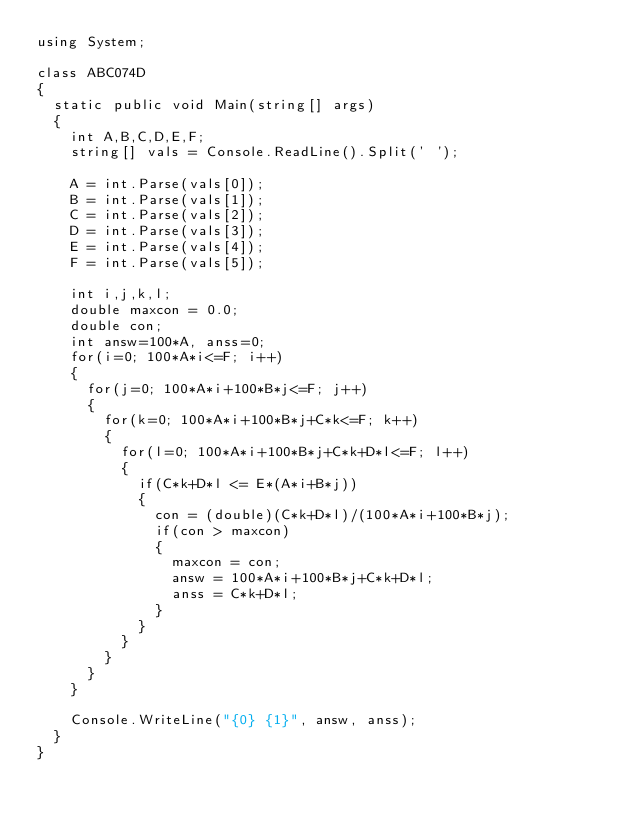Convert code to text. <code><loc_0><loc_0><loc_500><loc_500><_C#_>using System;

class ABC074D
{
	static public void Main(string[] args)
	{
		int A,B,C,D,E,F;
		string[] vals = Console.ReadLine().Split(' ');

		A = int.Parse(vals[0]);
		B = int.Parse(vals[1]);
		C = int.Parse(vals[2]);
		D = int.Parse(vals[3]);
		E = int.Parse(vals[4]);
		F = int.Parse(vals[5]);

		int i,j,k,l;
		double maxcon = 0.0;
		double con;
		int answ=100*A, anss=0;
		for(i=0; 100*A*i<=F; i++)
		{
			for(j=0; 100*A*i+100*B*j<=F; j++)
			{
				for(k=0; 100*A*i+100*B*j+C*k<=F; k++)
				{
					for(l=0; 100*A*i+100*B*j+C*k+D*l<=F; l++)
					{
						if(C*k+D*l <= E*(A*i+B*j))
						{
							con = (double)(C*k+D*l)/(100*A*i+100*B*j);
							if(con > maxcon)
							{
								maxcon = con;
								answ = 100*A*i+100*B*j+C*k+D*l;
								anss = C*k+D*l;
							}
						}
					}
				}
			}
		}

		Console.WriteLine("{0} {1}", answ, anss);
	}
}
</code> 